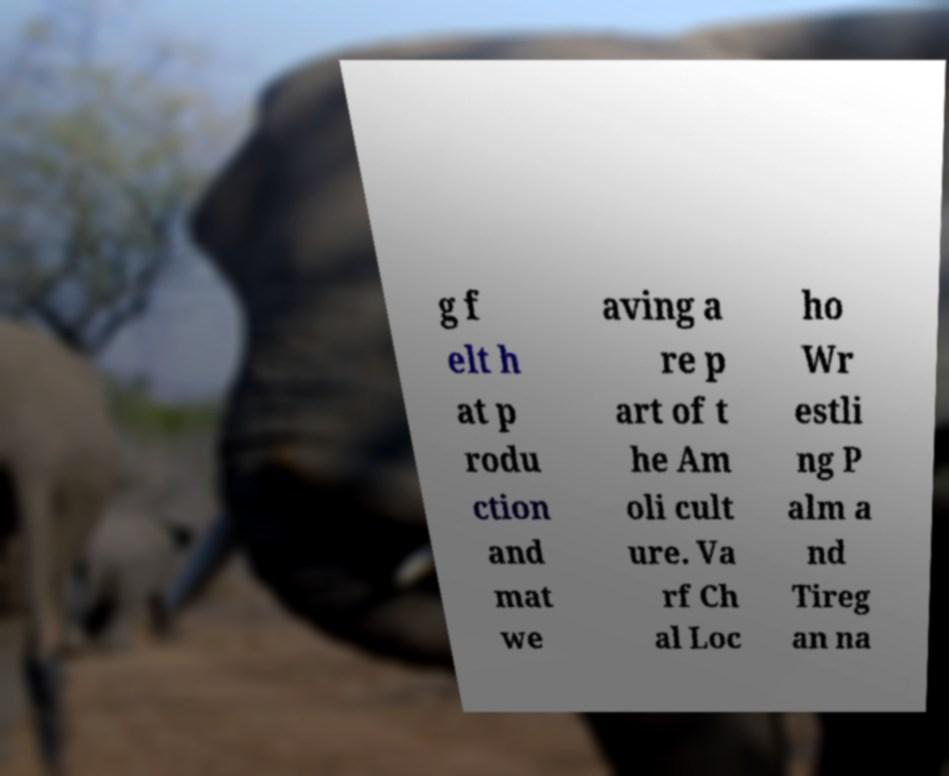I need the written content from this picture converted into text. Can you do that? g f elt h at p rodu ction and mat we aving a re p art of t he Am oli cult ure. Va rf Ch al Loc ho Wr estli ng P alm a nd Tireg an na 